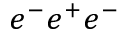<formula> <loc_0><loc_0><loc_500><loc_500>e ^ { - } e ^ { + } e ^ { - }</formula> 